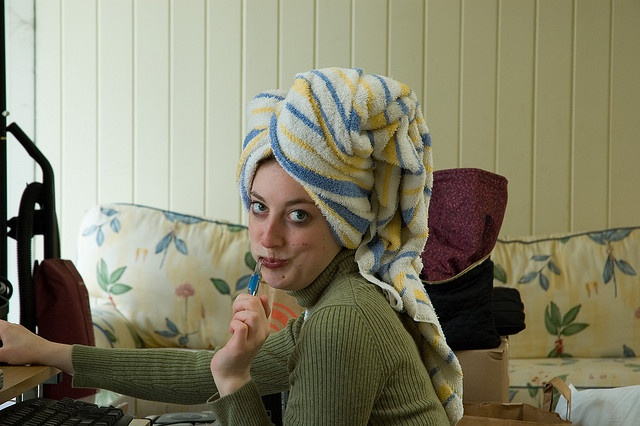Describe the objects in this image and their specific colors. I can see people in black, darkgreen, and gray tones, couch in black, olive, darkgray, and gray tones, keyboard in black, gray, and darkgray tones, and toothbrush in black, gray, and blue tones in this image. 